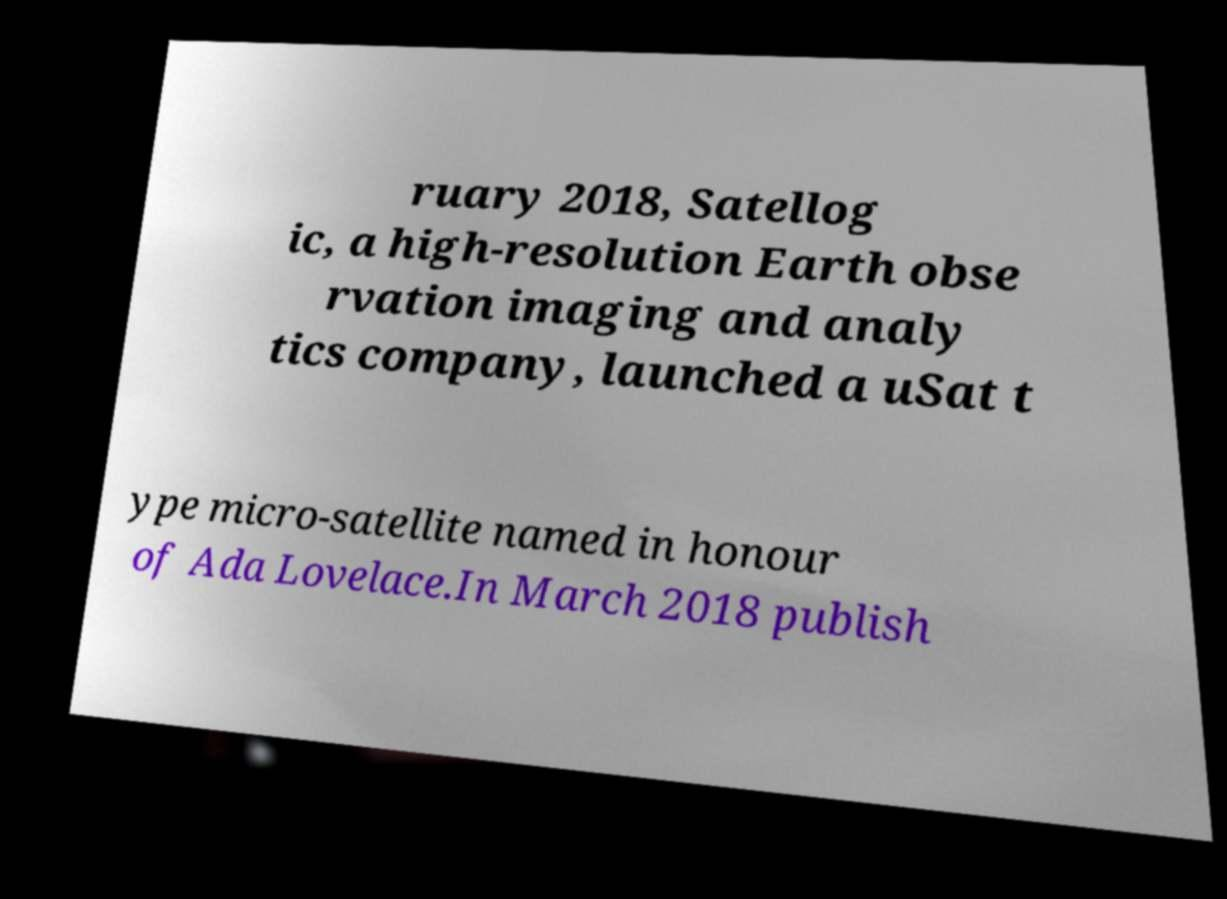Can you read and provide the text displayed in the image?This photo seems to have some interesting text. Can you extract and type it out for me? ruary 2018, Satellog ic, a high-resolution Earth obse rvation imaging and analy tics company, launched a uSat t ype micro-satellite named in honour of Ada Lovelace.In March 2018 publish 